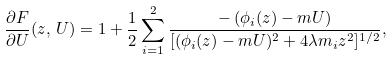Convert formula to latex. <formula><loc_0><loc_0><loc_500><loc_500>\frac { \partial F } { \partial U } ( z , \, U ) = 1 + \frac { 1 } { 2 } \sum _ { i = 1 } ^ { 2 } \frac { - \left ( \phi _ { i } ( z ) - m U \right ) } { [ ( \phi _ { i } ( z ) - m U ) ^ { 2 } + 4 \lambda m _ { i } z ^ { 2 } ] ^ { 1 / 2 } } ,</formula> 